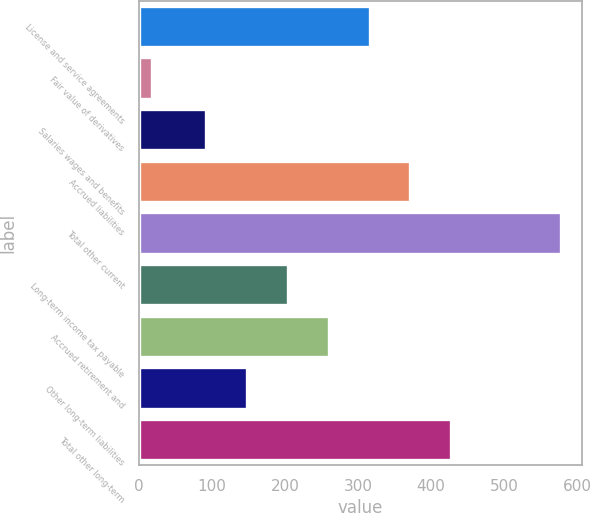Convert chart to OTSL. <chart><loc_0><loc_0><loc_500><loc_500><bar_chart><fcel>License and service agreements<fcel>Fair value of derivatives<fcel>Salaries wages and benefits<fcel>Accrued liabilities<fcel>Total other current<fcel>Long-term income tax payable<fcel>Accrued retirement and<fcel>Other long-term liabilities<fcel>Total other long-term<nl><fcel>315.66<fcel>17.7<fcel>91.5<fcel>371.7<fcel>578.1<fcel>203.58<fcel>259.62<fcel>147.54<fcel>427.74<nl></chart> 